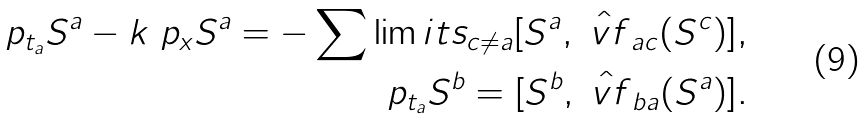Convert formula to latex. <formula><loc_0><loc_0><loc_500><loc_500>\ p _ { { t } _ { a } } S ^ { a } - k \ p _ { x } S ^ { a } = - \sum \lim i t s _ { c \neq a } [ S ^ { a } , \hat { \ v f } _ { a c } ( S ^ { c } ) ] , \\ \ p _ { { t } _ { a } } S ^ { b } = [ S ^ { b } , \hat { \ v f } _ { b a } ( S ^ { a } ) ] .</formula> 